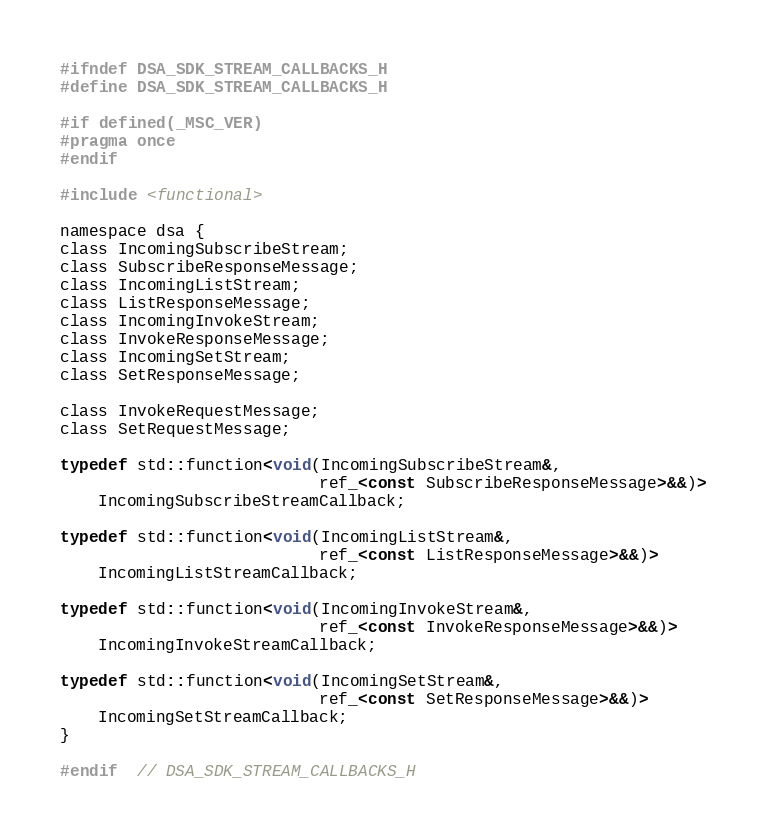Convert code to text. <code><loc_0><loc_0><loc_500><loc_500><_C_>#ifndef DSA_SDK_STREAM_CALLBACKS_H
#define DSA_SDK_STREAM_CALLBACKS_H

#if defined(_MSC_VER)
#pragma once
#endif

#include <functional>

namespace dsa {
class IncomingSubscribeStream;
class SubscribeResponseMessage;
class IncomingListStream;
class ListResponseMessage;
class IncomingInvokeStream;
class InvokeResponseMessage;
class IncomingSetStream;
class SetResponseMessage;

class InvokeRequestMessage;
class SetRequestMessage;

typedef std::function<void(IncomingSubscribeStream&,
                           ref_<const SubscribeResponseMessage>&&)>
    IncomingSubscribeStreamCallback;

typedef std::function<void(IncomingListStream&,
                           ref_<const ListResponseMessage>&&)>
    IncomingListStreamCallback;

typedef std::function<void(IncomingInvokeStream&,
                           ref_<const InvokeResponseMessage>&&)>
    IncomingInvokeStreamCallback;

typedef std::function<void(IncomingSetStream&,
                           ref_<const SetResponseMessage>&&)>
    IncomingSetStreamCallback;
}

#endif  // DSA_SDK_STREAM_CALLBACKS_H
</code> 